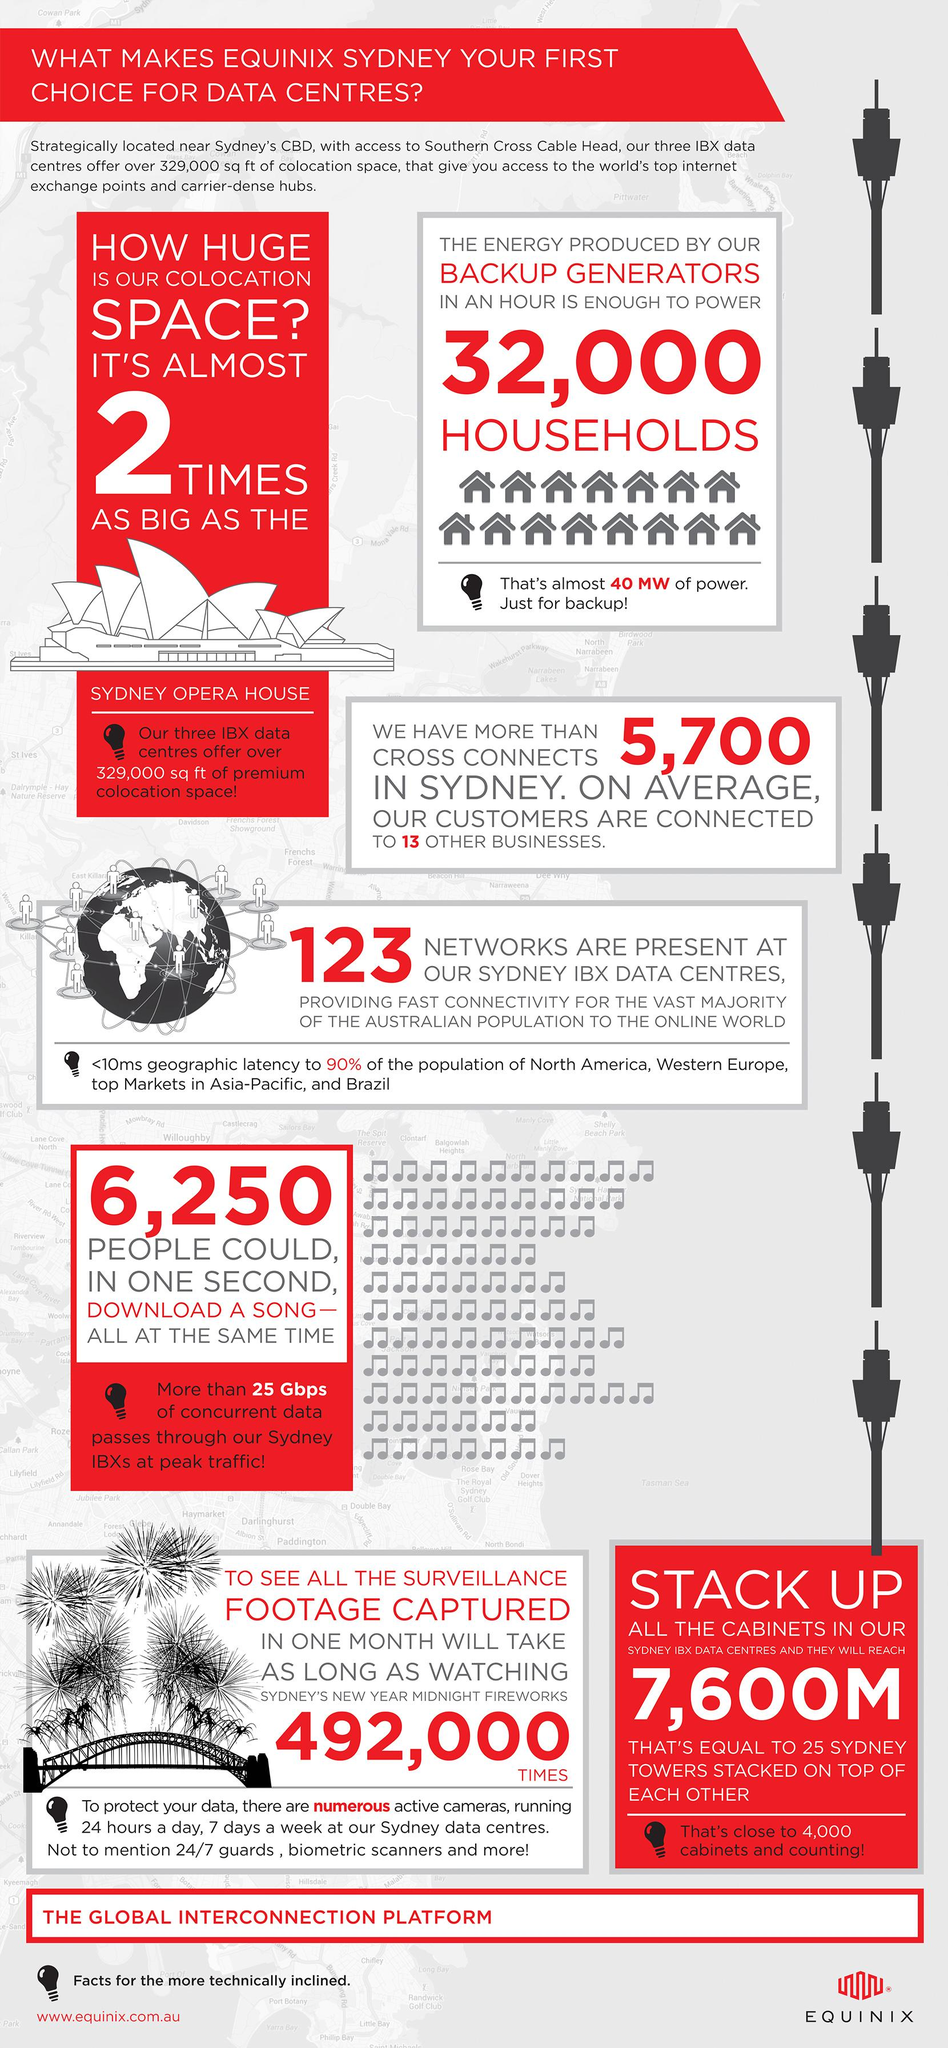Draw attention to some important aspects in this diagram. It is possible to download a song in one second for approximately 6,250 people if they all attempt to do so at the same time. The backup generators have the capacity to power approximately 32,000 households, providing reliable energy during outages. There are 123 networks at the Sydney IBX data centers. 